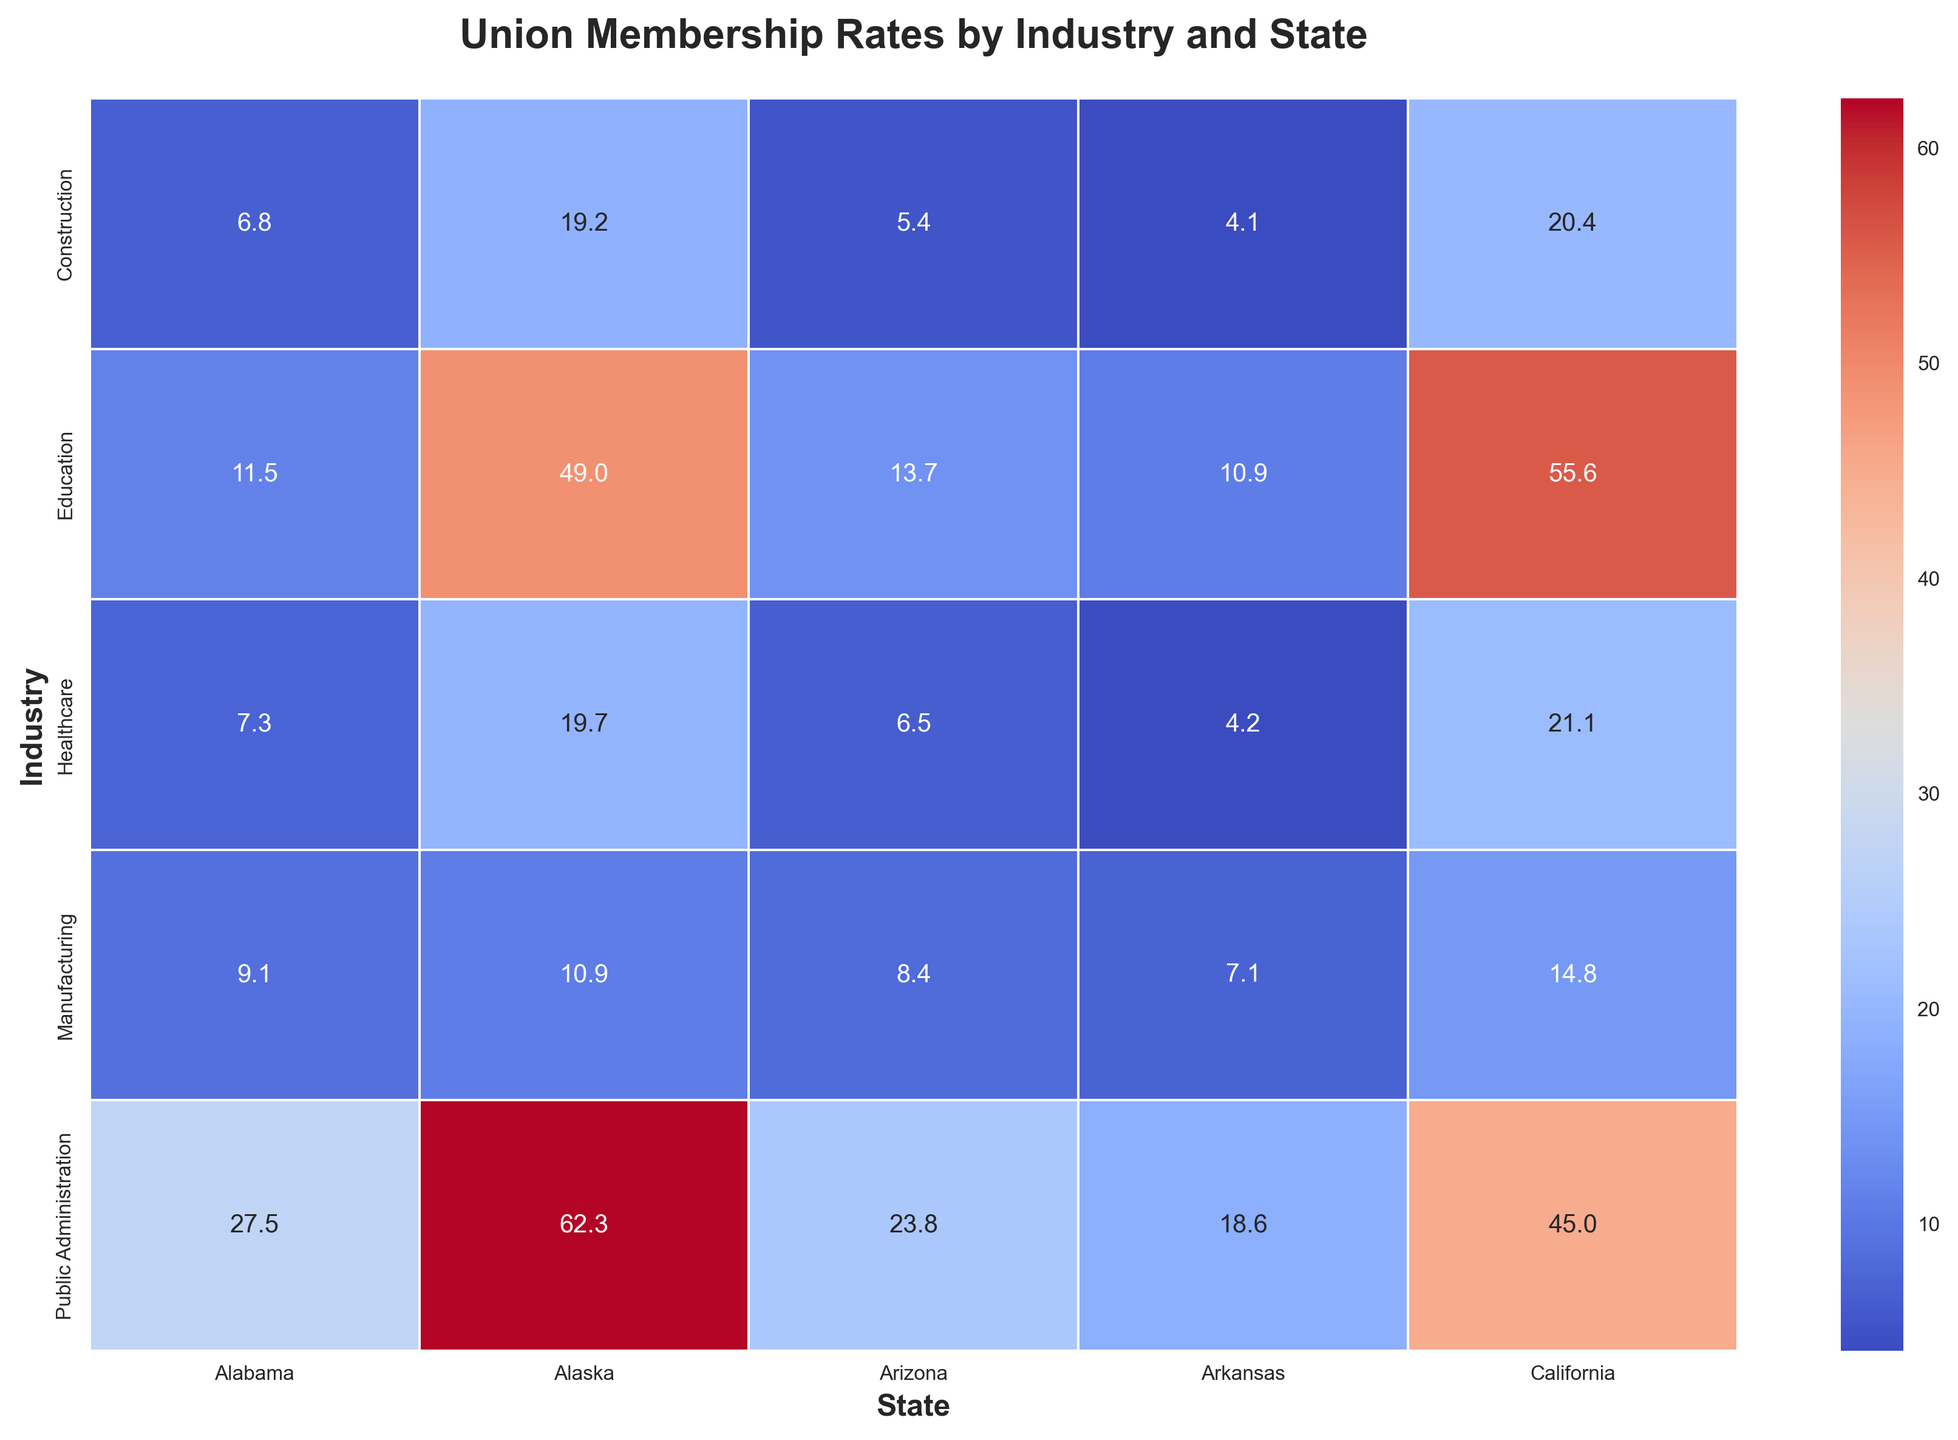Which state has the highest union membership rate in Public Administration? Look at the section for Public Administration and identify the highest number among the states. Alaska has the highest rate of 62.3.
Answer: Alaska Which industry has the lowest union membership rate in Arkansas? Examine the row for Arkansas and find the smallest number across all industries. The lowest rate in Arkansas is in Construction at 4.1.
Answer: Construction What is the difference in union membership rates in Healthcare between Alaska and California? Locate the union membership rates for Healthcare in Alaska (19.7) and California (21.1) and calculate the difference: 21.1 - 19.7 = 1.4.
Answer: 1.4 Which state has the most consistent union membership rates across all industries (smallest range)? Calculate the range (maximum - minimum) of union membership rates for each state and compare them. Alaska has the smallest range, with rates from 10.9 to 62.3, giving a range of 51.4.
Answer: Alaska In which industry does California have the highest union membership rate? Look at the column for California and identify the highest value across industries. Education has the highest rate with 55.6.
Answer: Education Which industry’s union membership rate is generally lower across most states, Healthcare or Manufacturing? Compare the union membership rates for Healthcare and Manufacturing across all states, and determine which industry has generally lower values. Healthcare generally has lower rates compared to Manufacturing.
Answer: Healthcare How much higher is the union membership rate in Education in Alaska compared to Arizona? Find the union membership rates for Education in Alaska (49.0) and Arizona (13.7), then subtract to find the difference: 49.0 - 13.7 = 35.3.
Answer: 35.3 Which state has the highest average union membership rate across all industries? Calculate the average union membership rate for each state by summing the rates across all industries and dividing by the number of industries. Alaska has the highest average rate.
Answer: Alaska Which state has the widest range of union membership rates across different industries? Determine the maximum and minimum union membership rates for each state and compute the range. Alaska, with rates from 10.9 to 62.3, has the widest range of 51.4.
Answer: Alaska Is the union membership rate in Construction significantly higher in California than in Arkansas? Check the rates for Construction in California (20.4) and Arkansas (4.1) and find the difference: 20.4 - 4.1 = 16.3, which is significantly higher.
Answer: Yes 